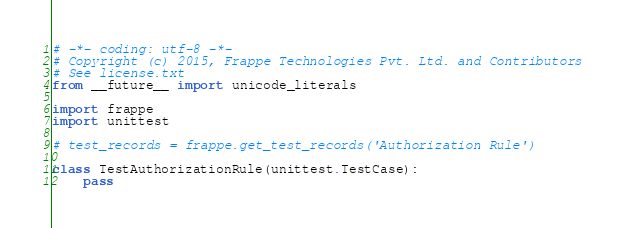<code> <loc_0><loc_0><loc_500><loc_500><_Python_># -*- coding: utf-8 -*-
# Copyright (c) 2015, Frappe Technologies Pvt. Ltd. and Contributors
# See license.txt
from __future__ import unicode_literals

import frappe
import unittest

# test_records = frappe.get_test_records('Authorization Rule')

class TestAuthorizationRule(unittest.TestCase):
	pass
</code> 